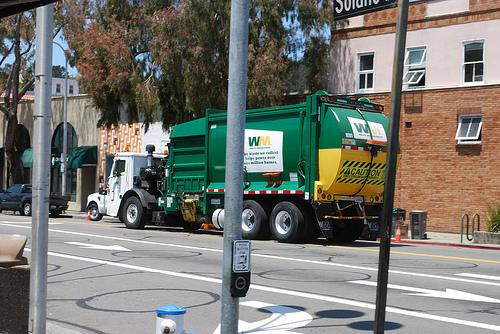Question: what is parked on the side of the road?
Choices:
A. Motorcycle.
B. Truck.
C. Car.
D. Bus.
Answer with the letter. Answer: B Question: what is near the truck?
Choices:
A. Building.
B. A fire hydrant.
C. A stop sign.
D. A parking garage.
Answer with the letter. Answer: A Question: where is the tree?
Choices:
A. In the front yard.
B. Next to the house.
C. Above truck.
D. In the courtyard.
Answer with the letter. Answer: C 